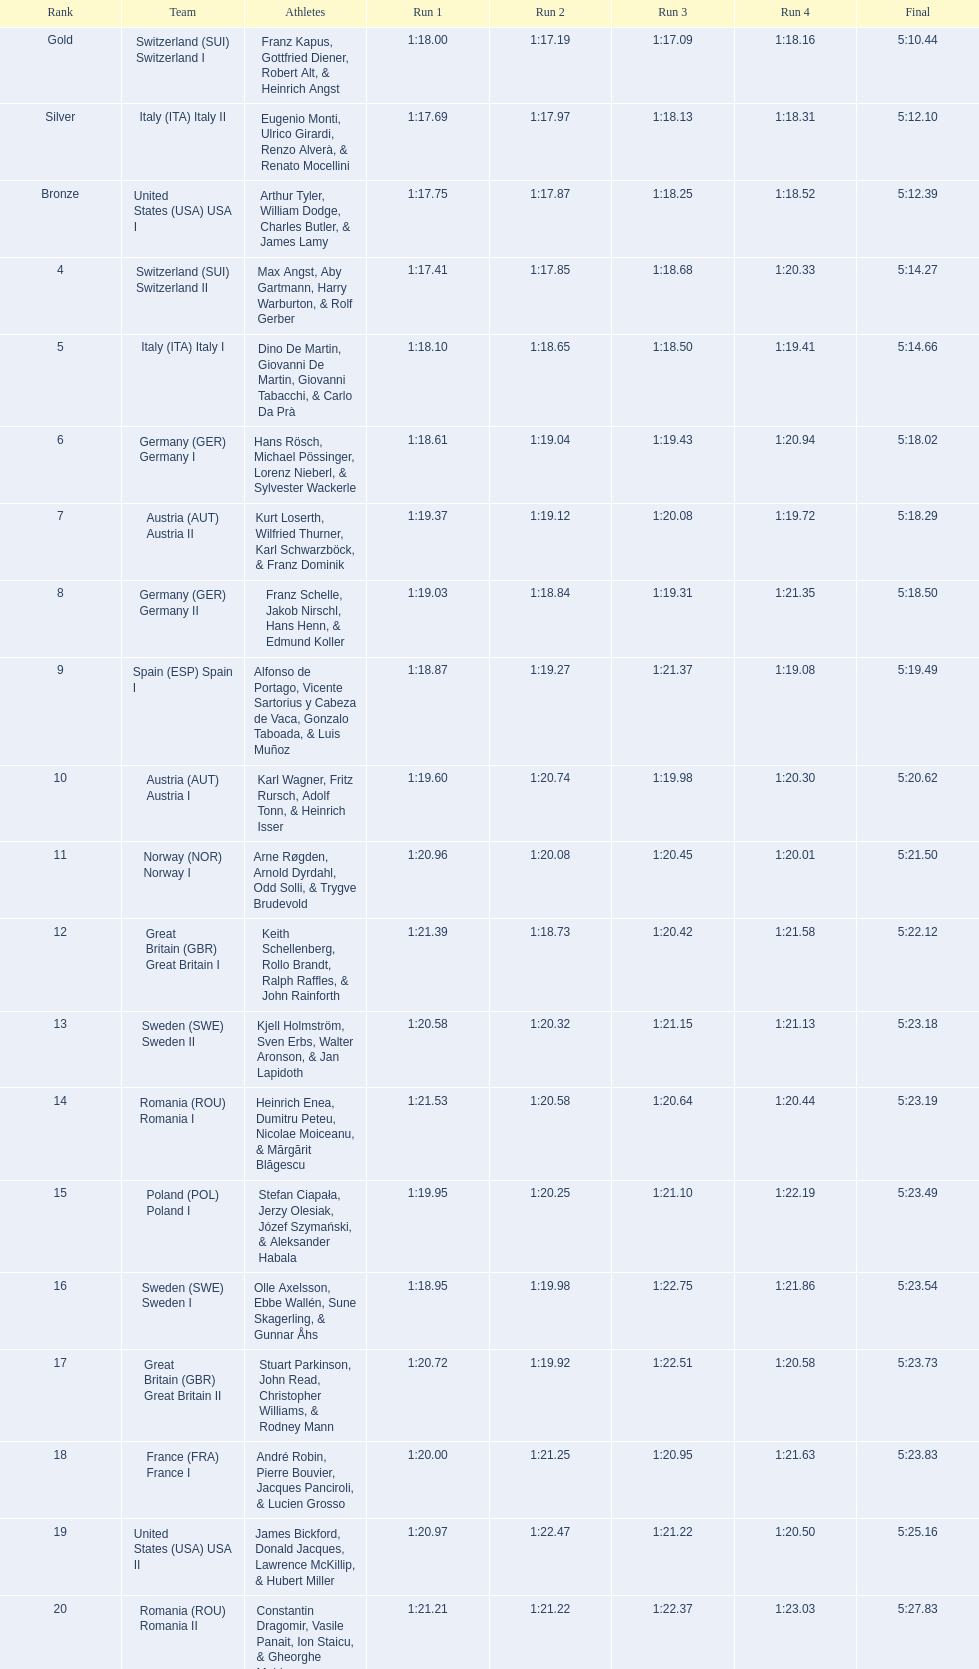What team came in second to last place? Romania. 